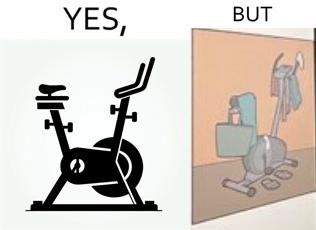Is there satirical content in this image? Yes, this image is satirical. 